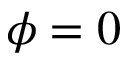<formula> <loc_0><loc_0><loc_500><loc_500>\phi = 0</formula> 